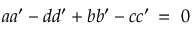Convert formula to latex. <formula><loc_0><loc_0><loc_500><loc_500>a a ^ { \prime } - d d ^ { \prime } + b b ^ { \prime } - c c ^ { \prime } \, = \, 0</formula> 